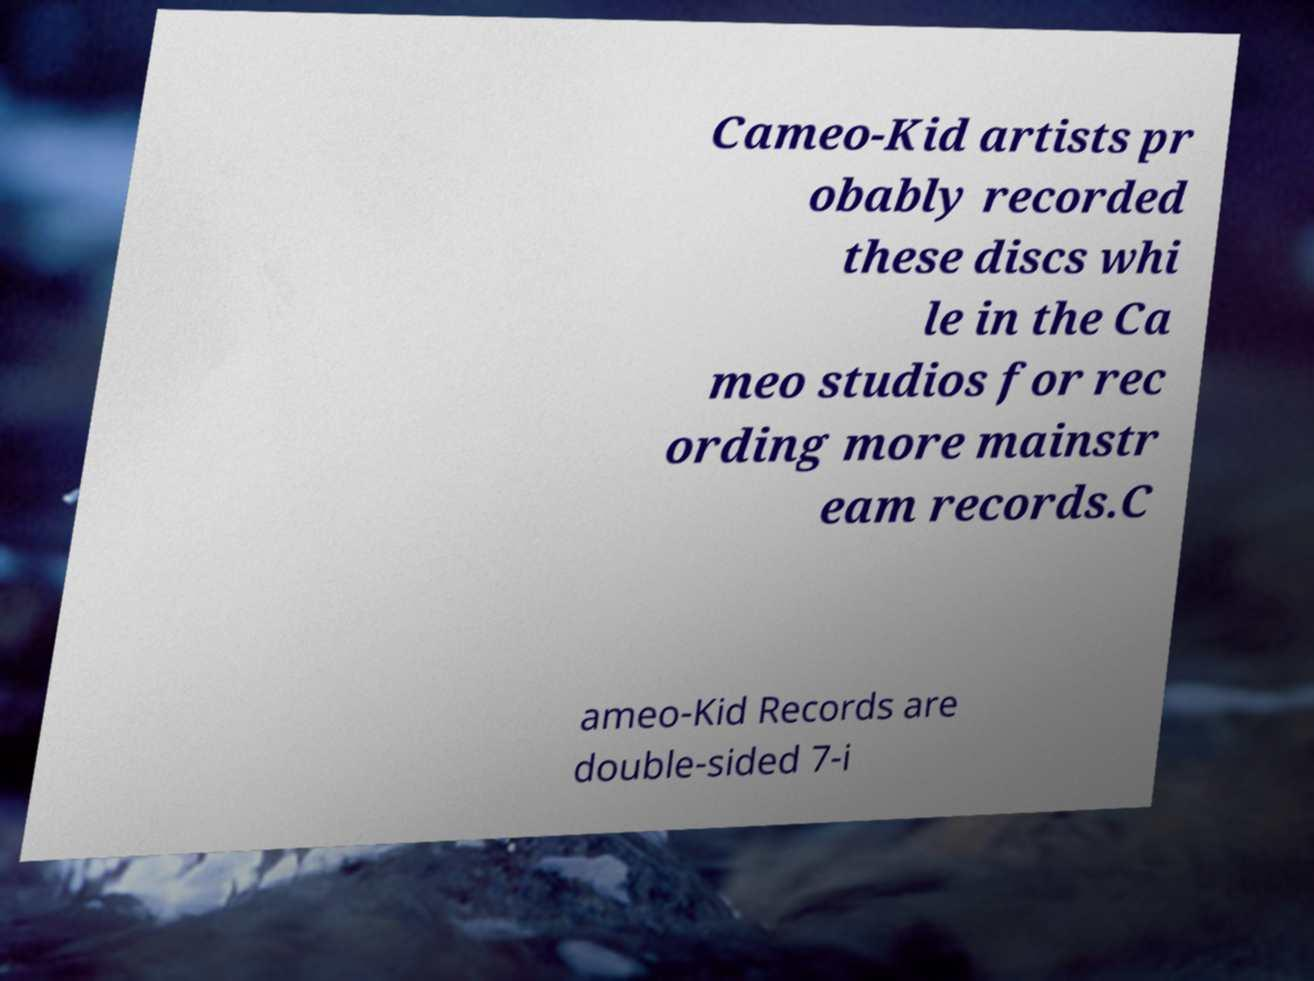Please identify and transcribe the text found in this image. Cameo-Kid artists pr obably recorded these discs whi le in the Ca meo studios for rec ording more mainstr eam records.C ameo-Kid Records are double-sided 7-i 